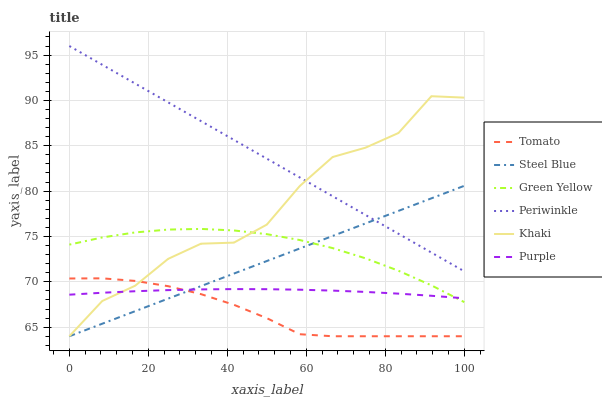Does Khaki have the minimum area under the curve?
Answer yes or no. No. Does Khaki have the maximum area under the curve?
Answer yes or no. No. Is Purple the smoothest?
Answer yes or no. No. Is Purple the roughest?
Answer yes or no. No. Does Purple have the lowest value?
Answer yes or no. No. Does Khaki have the highest value?
Answer yes or no. No. Is Green Yellow less than Periwinkle?
Answer yes or no. Yes. Is Periwinkle greater than Tomato?
Answer yes or no. Yes. Does Green Yellow intersect Periwinkle?
Answer yes or no. No. 